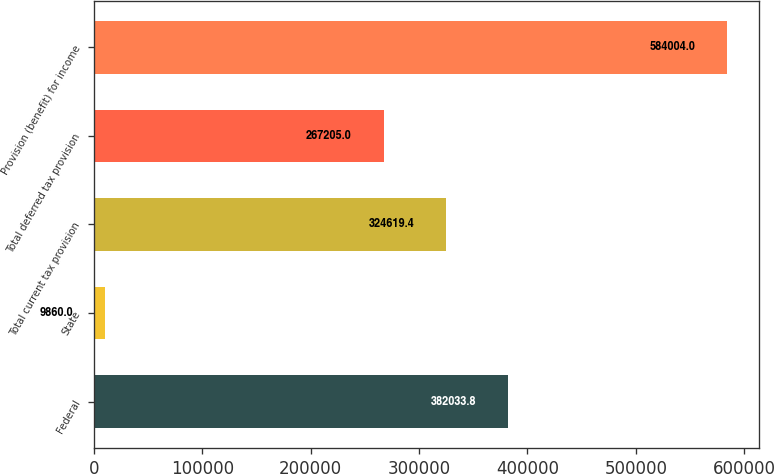<chart> <loc_0><loc_0><loc_500><loc_500><bar_chart><fcel>Federal<fcel>State<fcel>Total current tax provision<fcel>Total deferred tax provision<fcel>Provision (benefit) for income<nl><fcel>382034<fcel>9860<fcel>324619<fcel>267205<fcel>584004<nl></chart> 